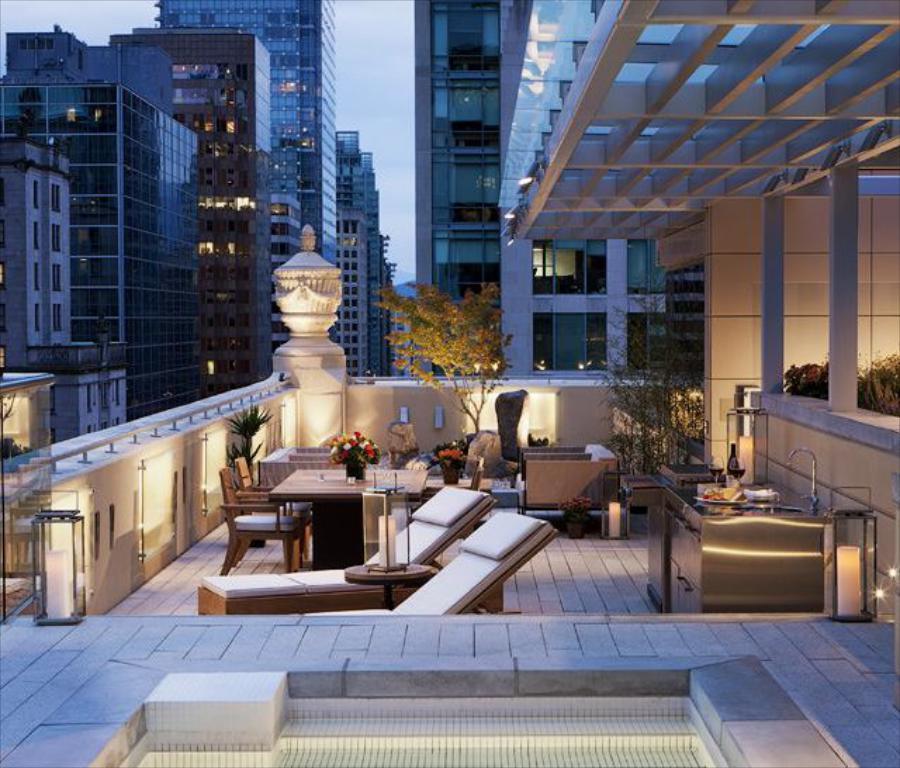Could you give a brief overview of what you see in this image? In this picture we can see building and in front here is a top of building where we have tables, chairs, trees and on table there is flower vase and i think this is a swimming pool and above building we have sky. 